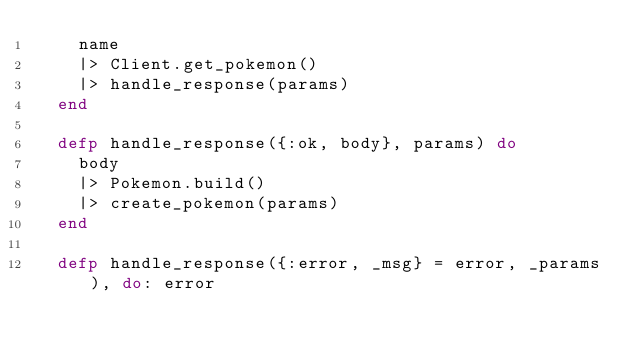<code> <loc_0><loc_0><loc_500><loc_500><_Elixir_>    name
    |> Client.get_pokemon()
    |> handle_response(params)
  end

  defp handle_response({:ok, body}, params) do
    body
    |> Pokemon.build()
    |> create_pokemon(params)
  end

  defp handle_response({:error, _msg} = error, _params), do: error
</code> 